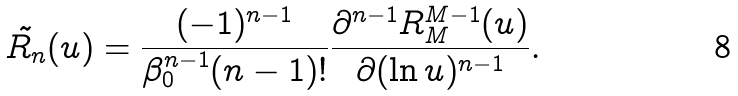<formula> <loc_0><loc_0><loc_500><loc_500>\tilde { R _ { n } } ( u ) = \frac { ( - 1 ) ^ { n - 1 } } { \beta _ { 0 } ^ { n - 1 } ( n - 1 ) ! } \frac { \partial ^ { n - 1 } R _ { M } ^ { M - 1 } ( u ) } { \partial ( \ln u ) ^ { n - 1 } } .</formula> 